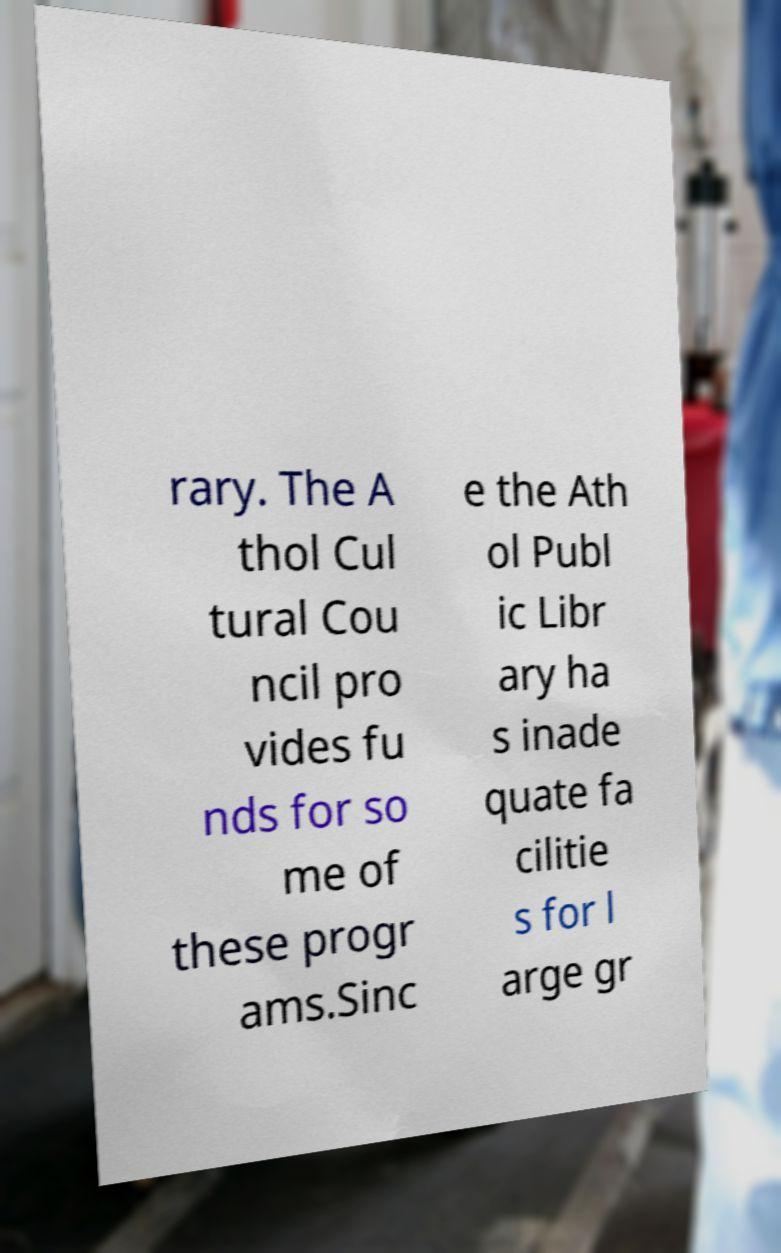What messages or text are displayed in this image? I need them in a readable, typed format. rary. The A thol Cul tural Cou ncil pro vides fu nds for so me of these progr ams.Sinc e the Ath ol Publ ic Libr ary ha s inade quate fa cilitie s for l arge gr 